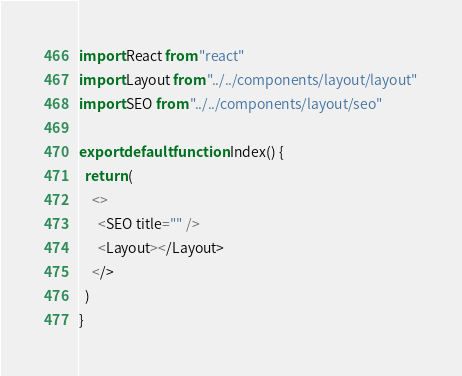<code> <loc_0><loc_0><loc_500><loc_500><_JavaScript_>import React from "react"
import Layout from "../../components/layout/layout"
import SEO from "../../components/layout/seo"

export default function Index() {
  return (
    <>
      <SEO title="" />
      <Layout></Layout>
    </>
  )
}
</code> 